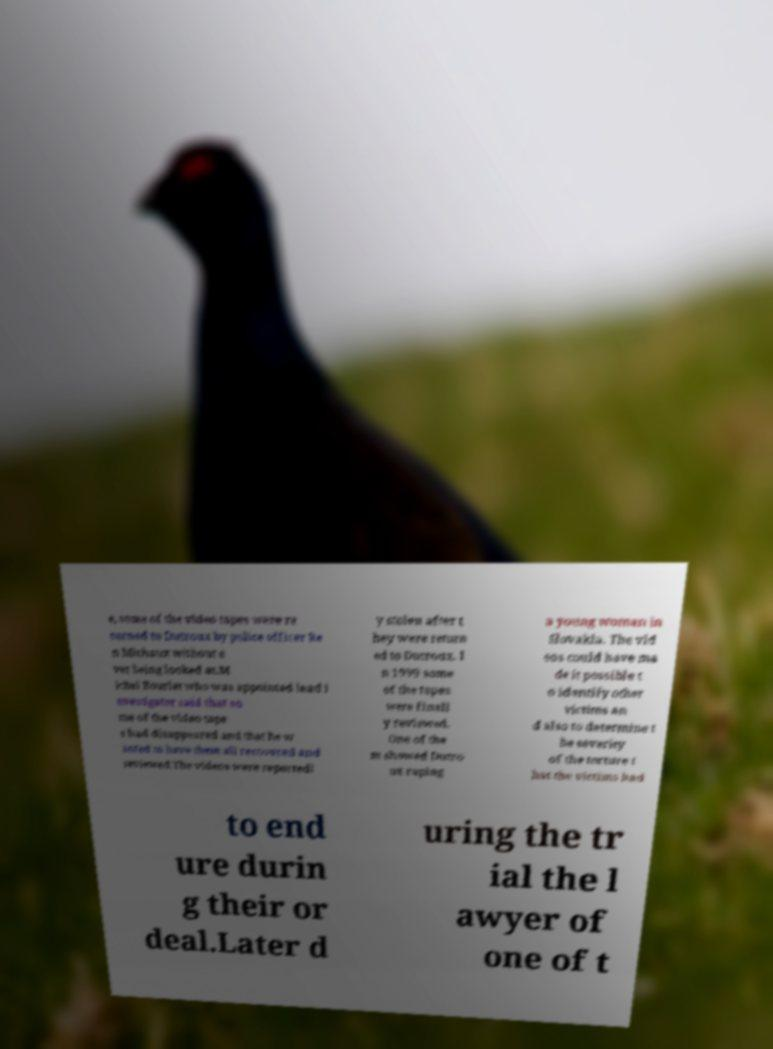Could you assist in decoding the text presented in this image and type it out clearly? e, some of the video tapes were re turned to Dutroux by police officer Re n Michaux without e ver being looked at.M ichel Bourlet who was appointed lead i nvestigator said that so me of the video tape s had disappeared and that he w anted to have them all recovered and reviewed.The videos were reportedl y stolen after t hey were return ed to Dutroux. I n 1999 some of the tapes were finall y reviewed. One of the m showed Dutro ux raping a young woman in Slovakia. The vid eos could have ma de it possible t o identify other victims an d also to determine t he severity of the torture t hat the victims had to end ure durin g their or deal.Later d uring the tr ial the l awyer of one of t 